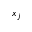<formula> <loc_0><loc_0><loc_500><loc_500>x _ { j }</formula> 